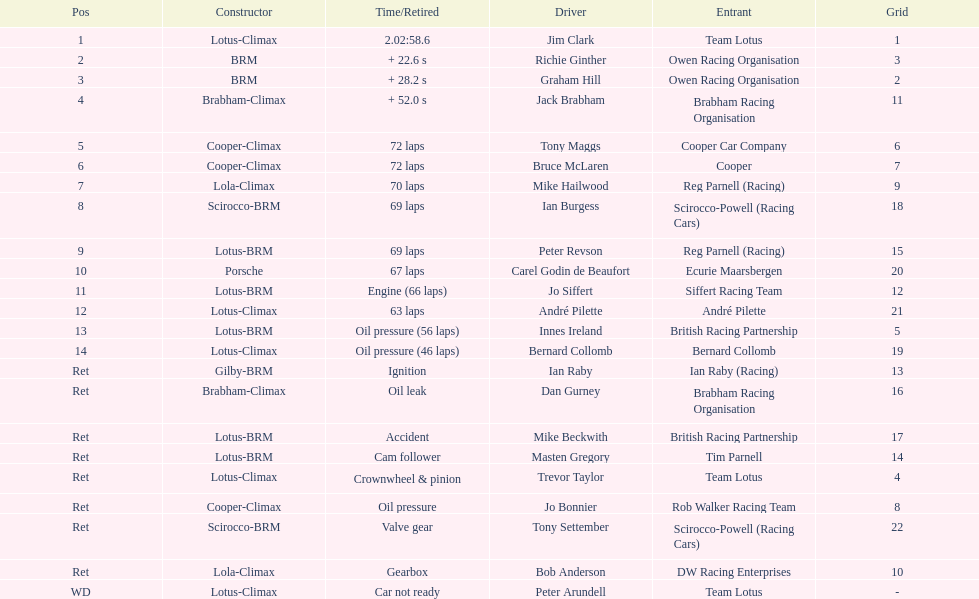Who was the top finisher that drove a cooper-climax? Tony Maggs. 